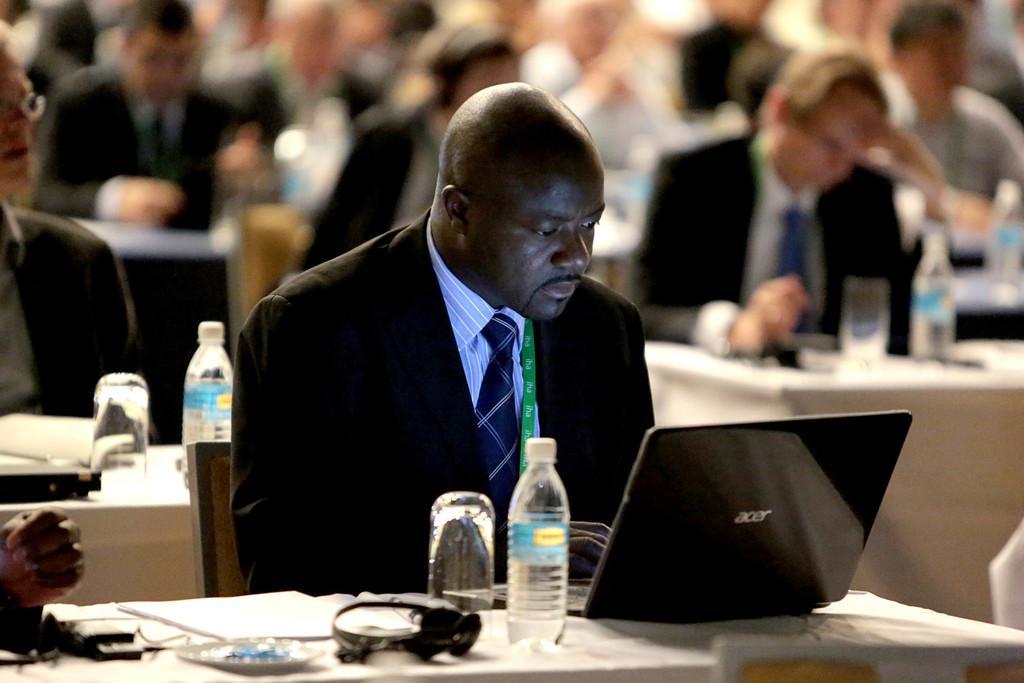Can you describe this image briefly? People are sitting at tables looking into their laptops. 